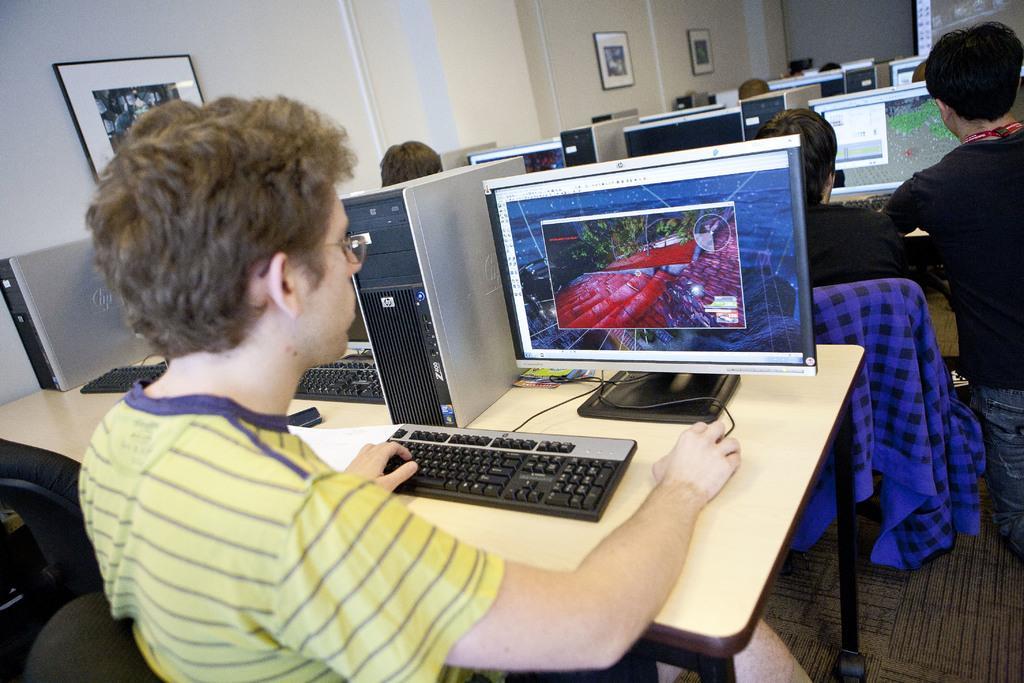How would you summarize this image in a sentence or two? Bottom left side of the image a man is sitting and looking in to a screen. Behind him there is a table, on the table there is a keyboard, CPU, screen, mouse. Behind them few people are sitting and there are some screens. Top left side of the image there is a wall, on the wall there are some frames. 